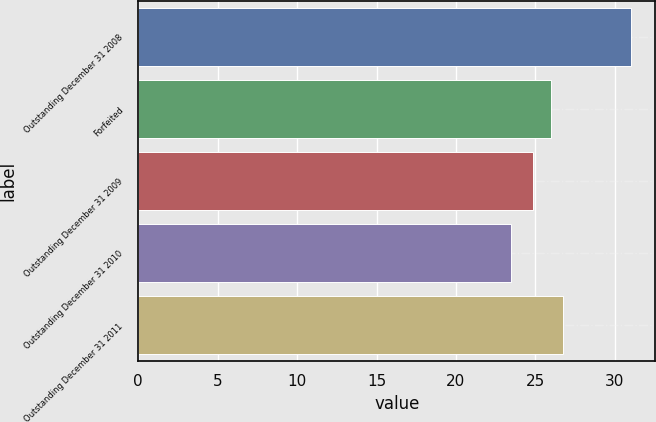Convert chart. <chart><loc_0><loc_0><loc_500><loc_500><bar_chart><fcel>Outstanding December 31 2008<fcel>Forfeited<fcel>Outstanding December 31 2009<fcel>Outstanding December 31 2010<fcel>Outstanding December 31 2011<nl><fcel>31<fcel>25.98<fcel>24.87<fcel>23.44<fcel>26.74<nl></chart> 